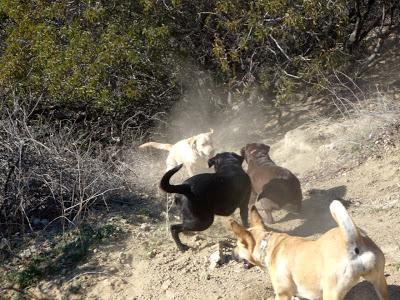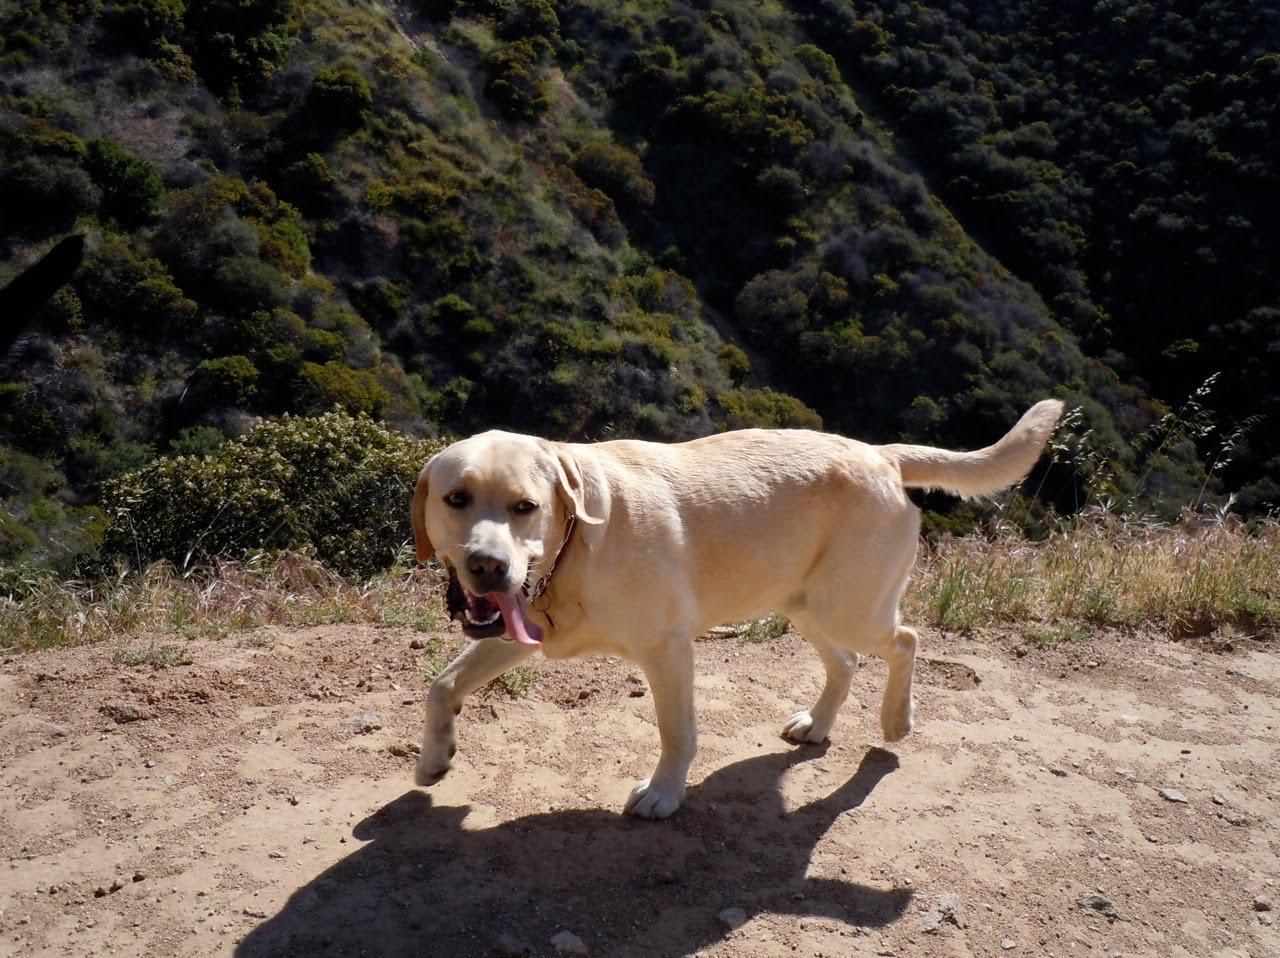The first image is the image on the left, the second image is the image on the right. Examine the images to the left and right. Is the description "An image shows dogs in a wet area and includes one black dog with at least six """"blond"""" ones." accurate? Answer yes or no. No. The first image is the image on the left, the second image is the image on the right. For the images shown, is this caption "There's no more than three dogs in the right image." true? Answer yes or no. Yes. 